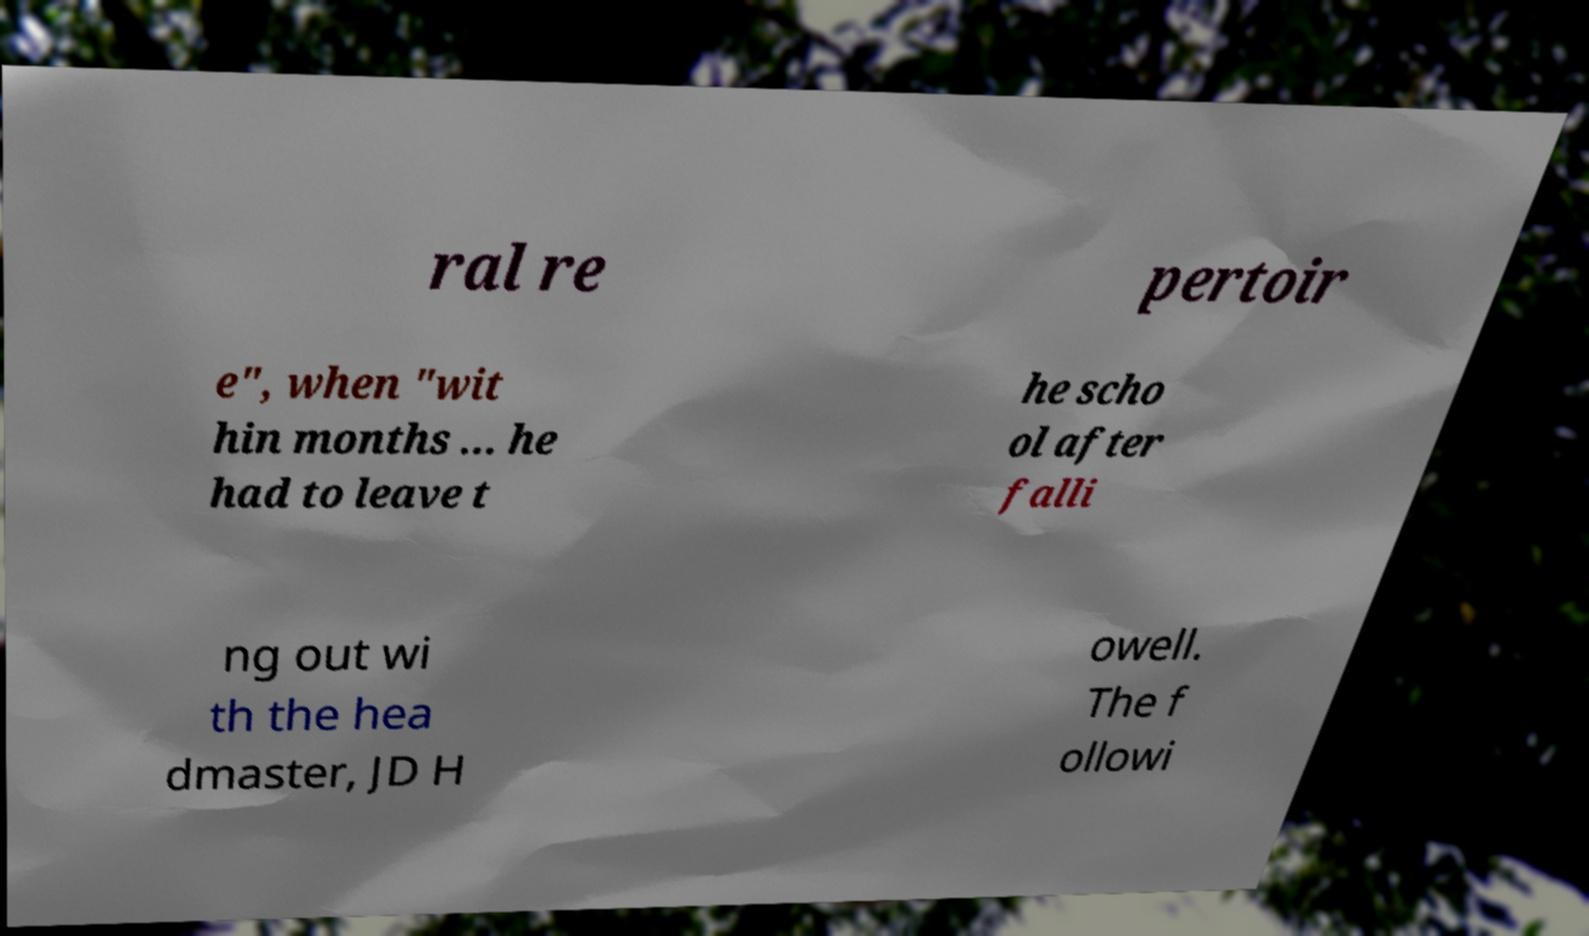I need the written content from this picture converted into text. Can you do that? ral re pertoir e", when "wit hin months ... he had to leave t he scho ol after falli ng out wi th the hea dmaster, JD H owell. The f ollowi 